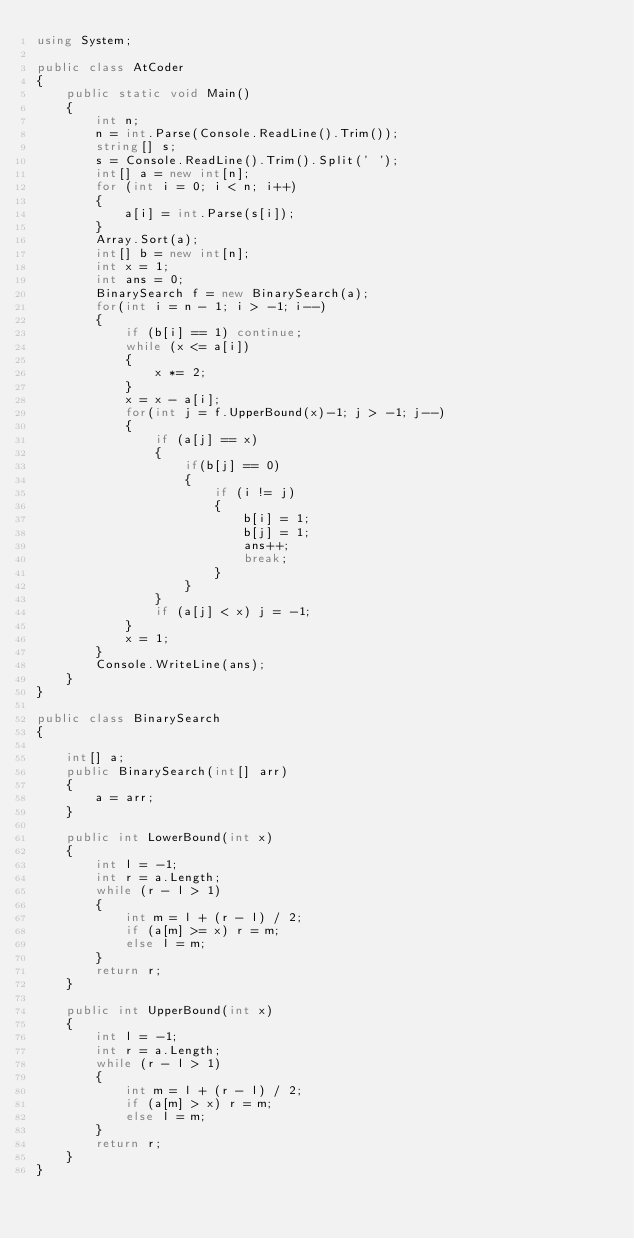Convert code to text. <code><loc_0><loc_0><loc_500><loc_500><_C#_>using System;

public class AtCoder
{
    public static void Main()
    {
        int n;
        n = int.Parse(Console.ReadLine().Trim());
        string[] s;
        s = Console.ReadLine().Trim().Split(' ');
        int[] a = new int[n];
        for (int i = 0; i < n; i++)
        {
            a[i] = int.Parse(s[i]);
        }
        Array.Sort(a);
        int[] b = new int[n];
        int x = 1;
        int ans = 0;
        BinarySearch f = new BinarySearch(a);
        for(int i = n - 1; i > -1; i--)
        {
            if (b[i] == 1) continue;
            while (x <= a[i])
            {
                x *= 2;
            }
            x = x - a[i];
            for(int j = f.UpperBound(x)-1; j > -1; j--)
            {                
                if (a[j] == x)
                {
                    if(b[j] == 0)
                    {
                        if (i != j)
                        {
                            b[i] = 1;
                            b[j] = 1;
                            ans++;
                            break;
                        }                       
                    }
                }
                if (a[j] < x) j = -1;
            }
            x = 1;
        }
        Console.WriteLine(ans);
    }
}

public class BinarySearch
{

    int[] a;
    public BinarySearch(int[] arr)
    {
        a = arr;
    }

    public int LowerBound(int x)
    {
        int l = -1;
        int r = a.Length;
        while (r - l > 1)
        {
            int m = l + (r - l) / 2;
            if (a[m] >= x) r = m;
            else l = m;
        }
        return r;
    }

    public int UpperBound(int x)
    {
        int l = -1;
        int r = a.Length;
        while (r - l > 1)
        {
            int m = l + (r - l) / 2;
            if (a[m] > x) r = m;
            else l = m;
        }
        return r;
    }
}
</code> 